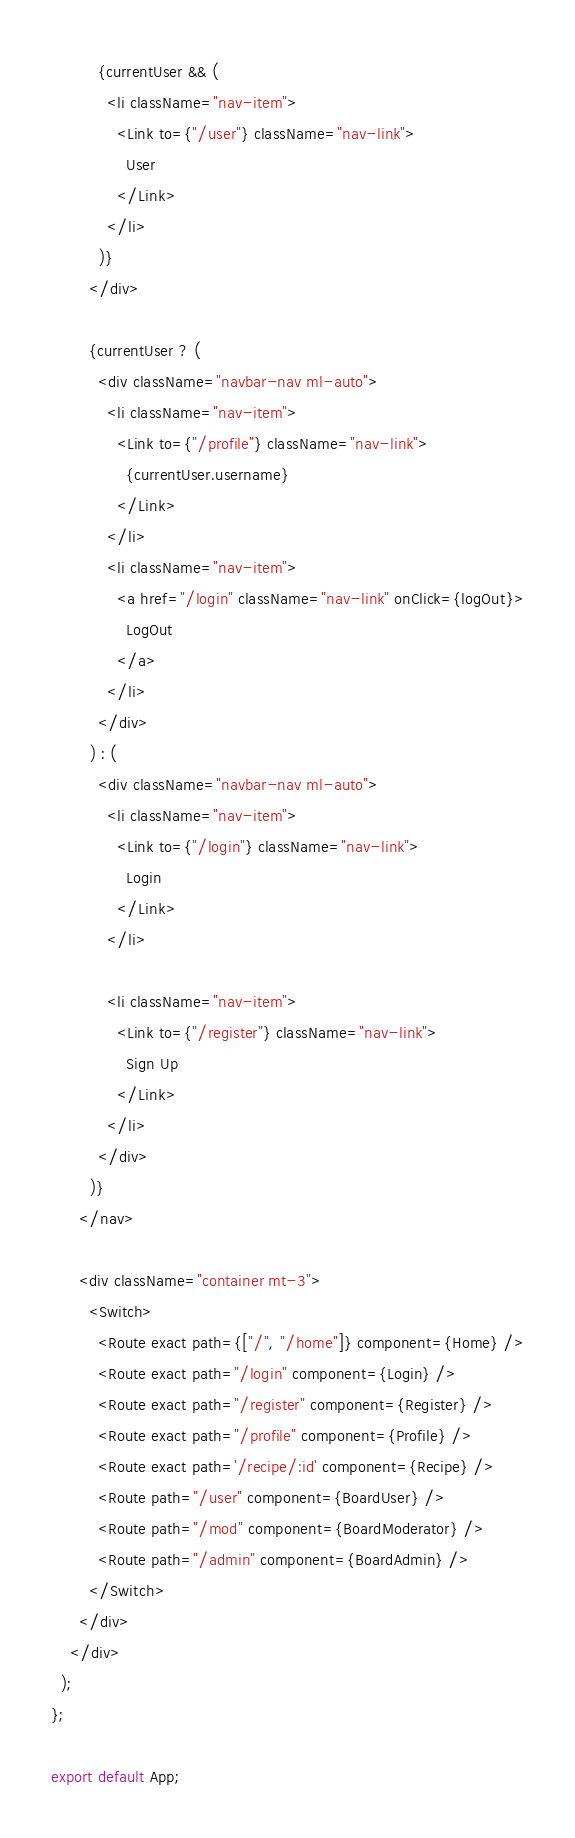<code> <loc_0><loc_0><loc_500><loc_500><_JavaScript_>          {currentUser && (
            <li className="nav-item">
              <Link to={"/user"} className="nav-link">
                User
              </Link>
            </li>
          )}
        </div>

        {currentUser ? (
          <div className="navbar-nav ml-auto">
            <li className="nav-item">
              <Link to={"/profile"} className="nav-link">
                {currentUser.username}
              </Link>
            </li>
            <li className="nav-item">
              <a href="/login" className="nav-link" onClick={logOut}>
                LogOut
              </a>
            </li>
          </div>
        ) : (
          <div className="navbar-nav ml-auto">
            <li className="nav-item">
              <Link to={"/login"} className="nav-link">
                Login
              </Link>
            </li>

            <li className="nav-item">
              <Link to={"/register"} className="nav-link">
                Sign Up
              </Link>
            </li>
          </div>
        )}
      </nav>

      <div className="container mt-3">
        <Switch>
          <Route exact path={["/", "/home"]} component={Home} />
          <Route exact path="/login" component={Login} />
          <Route exact path="/register" component={Register} />
          <Route exact path="/profile" component={Profile} />
          <Route exact path='/recipe/:id' component={Recipe} />
          <Route path="/user" component={BoardUser} />
          <Route path="/mod" component={BoardModerator} />
          <Route path="/admin" component={BoardAdmin} />
        </Switch>
      </div>
    </div>
  );
};

export default App;</code> 